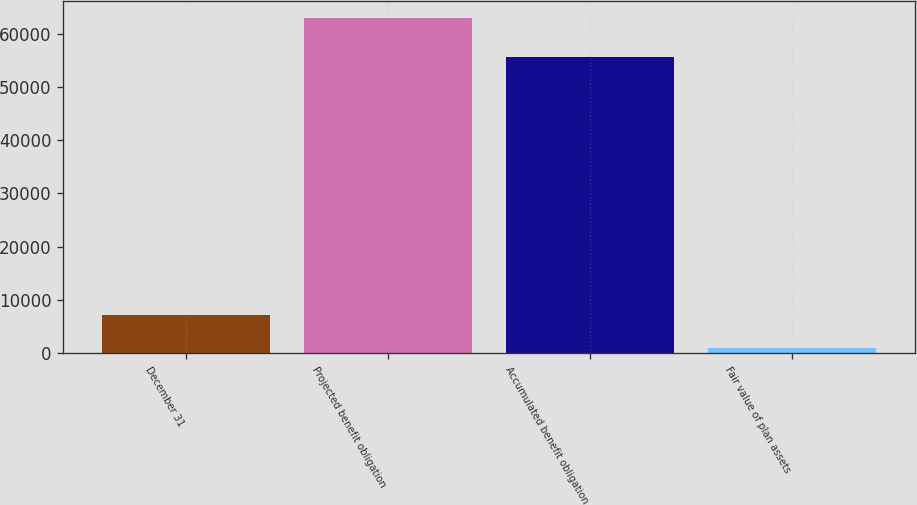Convert chart to OTSL. <chart><loc_0><loc_0><loc_500><loc_500><bar_chart><fcel>December 31<fcel>Projected benefit obligation<fcel>Accumulated benefit obligation<fcel>Fair value of plan assets<nl><fcel>7180.7<fcel>63014<fcel>55623<fcel>977<nl></chart> 